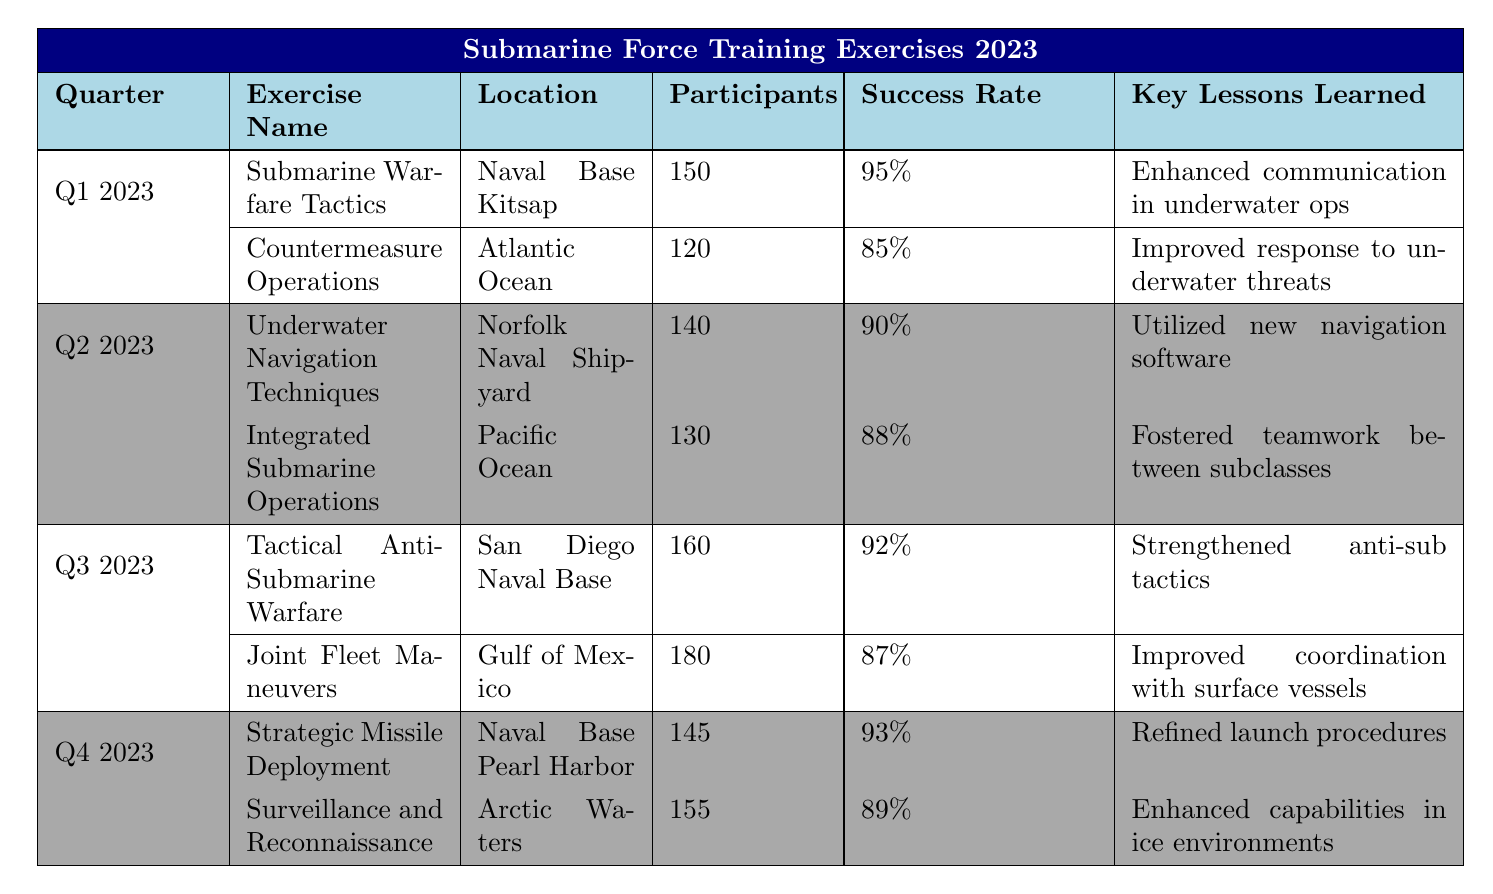What is the success rate of the "Countermeasure Operations" exercise? The "Countermeasure Operations" exercise is listed under Q1 2023, where the success rate is stated as 85%.
Answer: 85% How many participants were involved in the "Joint Fleet Maneuvers" exercise? The "Joint Fleet Maneuvers" exercise, which took place in Q3 2023, had 180 participants.
Answer: 180 Which quarter had the highest number of participants across all exercises? In Q3 2023, the number of participants (160 for "Tactical Anti-Submarine Warfare" and 180 for "Joint Fleet Maneuvers") totals 340, which is greater than any other quarter's totals (Q1: 270, Q2: 270, Q4: 300). Therefore, Q3 has the highest.
Answer: Q3 2023 What lesson was learned from the "Strategic Missile Deployment" exercise? The key lesson learned from the "Strategic Missile Deployment" exercise in Q4 2023 was refined launch procedures under high-pressure situations.
Answer: Refined launch procedures under high-pressure situations In which quarter did the "Underwater Navigation Techniques" exercise have a success rate of 90%? The "Underwater Navigation Techniques" exercise is listed under Q2 2023, where its success rate is stated as 90%.
Answer: Q2 2023 Which exercise had the lowest success rate, and what was it? The exercise with the lowest success rate is "Countermeasure Operations" at 85%, which is lower than the other exercises' success rates.
Answer: Countermeasure Operations, 85% How many total exercises were conducted across all quarters? There are 2 exercises per quarter across 4 quarters, giving a total of 2 * 4 = 8 exercises.
Answer: 8 What was the average success rate of all exercises conducted in Q4 2023? The success rates for Q4 2023 exercises are 93% and 89%. To find the average: (93 + 89) / 2 = 91%.
Answer: 91% Did any exercise in Q1 have a success rate above 90%? Yes, the "Submarine Warfare Tactics" exercise had a success rate of 95%, which is above 90%.
Answer: Yes Which exercise had the most participants in Q2 2023? The "Underwater Navigation Techniques" exercise had 140 participants, which is more than the 130 participants in "Integrated Submarine Operations."
Answer: Underwater Navigation Techniques If you sum the participants from all exercises in Q3 2023 and compare it with Q4 2023, in which quarter are there more participants? In Q3 2023, the total is 160 + 180 = 340 participants. In Q4 2023, it’s 145 + 155 = 300 participants. Therefore, Q3 has more participants than Q4.
Answer: Q3 2023 What was learned from the "Surveillance and Reconnaissance" exercise? The lesson learned was enhanced capabilities in ice-covered environments during the "Surveillance and Reconnaissance" exercise in Q4 2023.
Answer: Enhanced capabilities in ice-covered environments 